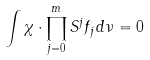Convert formula to latex. <formula><loc_0><loc_0><loc_500><loc_500>\int \chi \cdot \prod _ { j = 0 } ^ { m } S ^ { j } f _ { j } \, d \nu = 0</formula> 